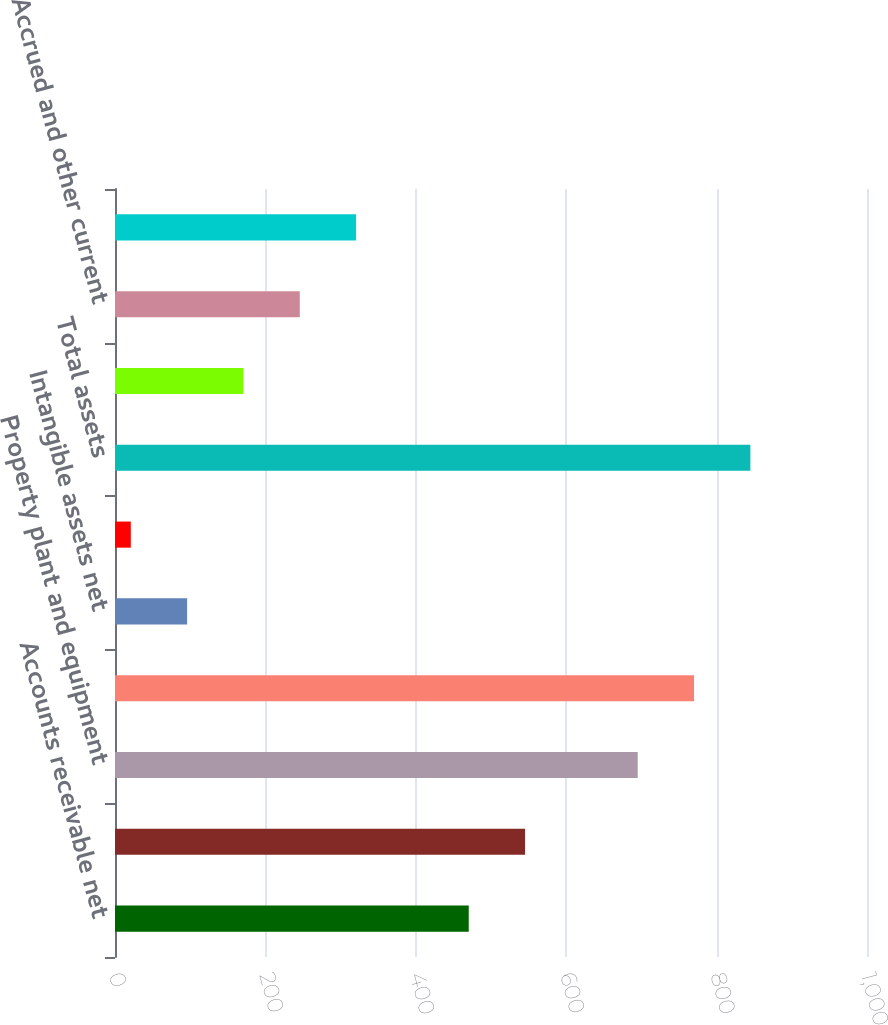Convert chart. <chart><loc_0><loc_0><loc_500><loc_500><bar_chart><fcel>Accounts receivable net<fcel>Inventories<fcel>Property plant and equipment<fcel>Goodwill<fcel>Intangible assets net<fcel>Other assets<fcel>Total assets<fcel>Accounts payable<fcel>Accrued and other current<fcel>Deferred revenue<nl><fcel>470.4<fcel>545.3<fcel>695.1<fcel>770<fcel>95.9<fcel>21<fcel>844.9<fcel>170.8<fcel>245.7<fcel>320.6<nl></chart> 